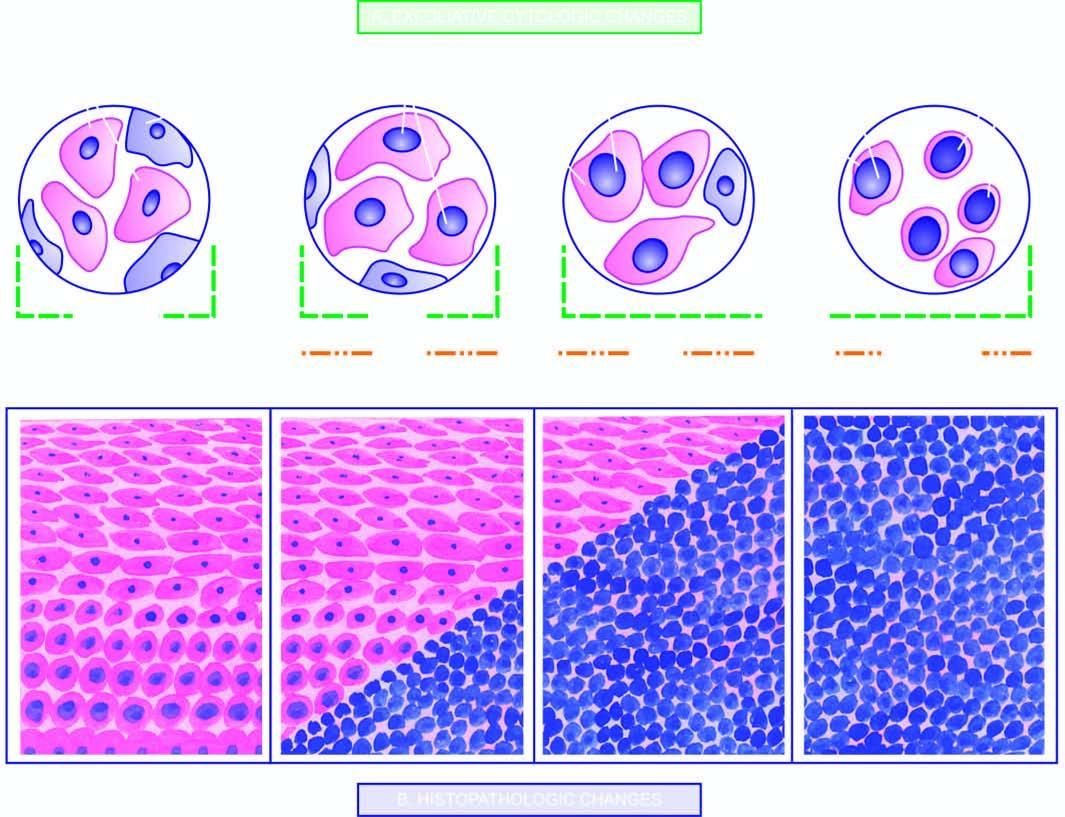do the grades of cin-1 or mild dysplasia show progressive increase in the number of abnormal cells parallel to the increasing severity of grades?
Answer the question using a single word or phrase. Yes 